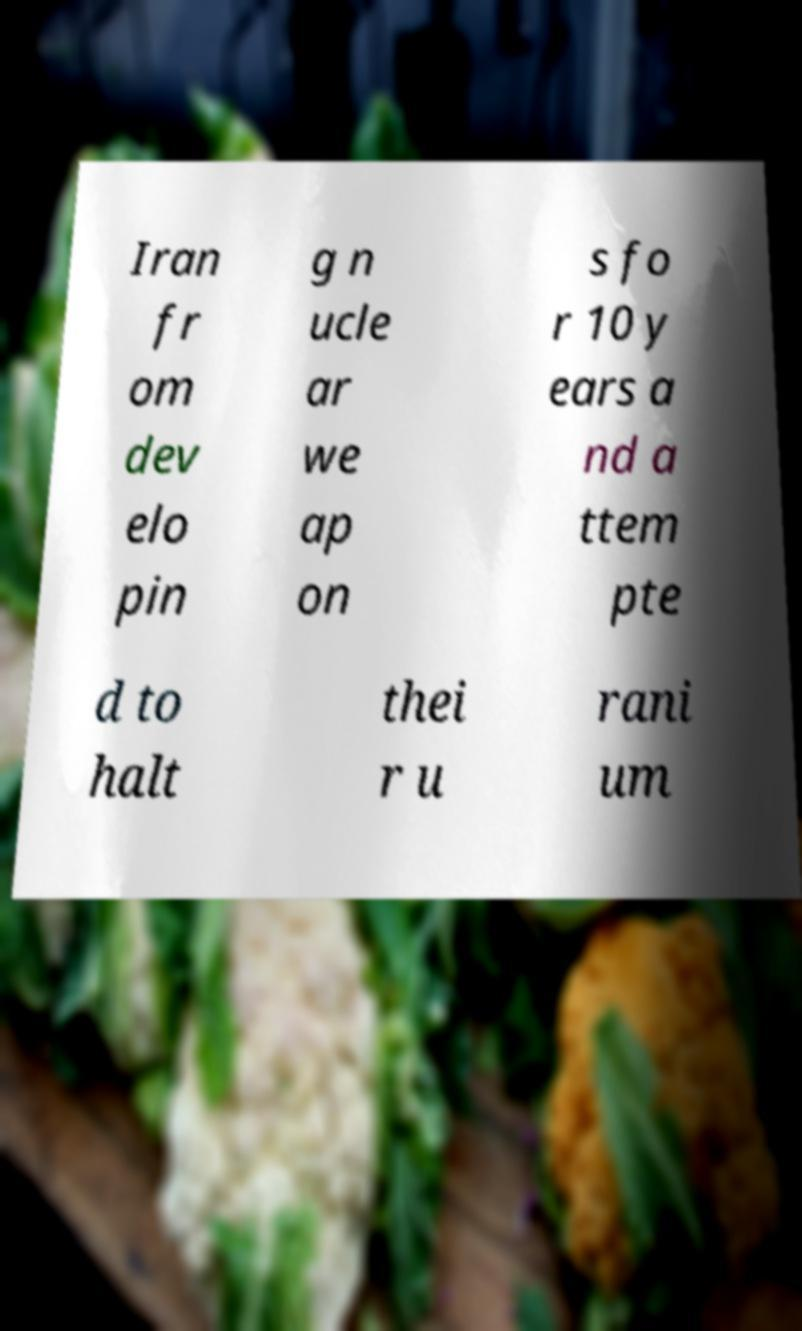There's text embedded in this image that I need extracted. Can you transcribe it verbatim? Iran fr om dev elo pin g n ucle ar we ap on s fo r 10 y ears a nd a ttem pte d to halt thei r u rani um 